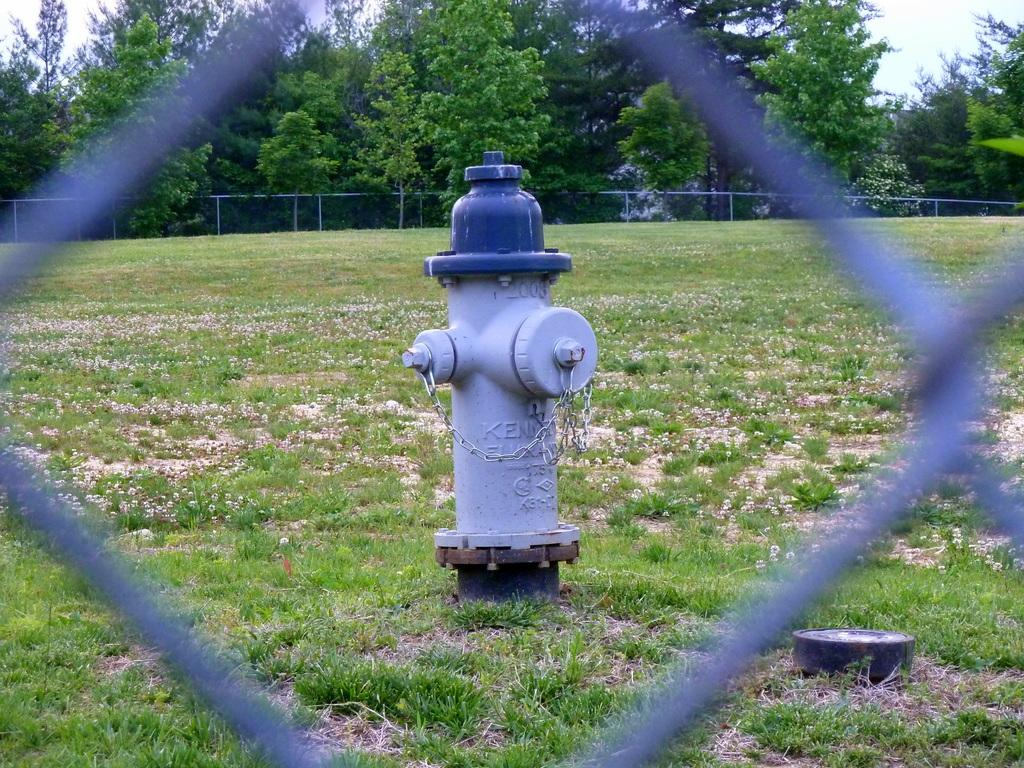What is the main object in the center of the image? There is a fire extinguisher in the center of the image. What can be seen in the foreground of the image? There is a fence in the foreground of the image. What type of vegetation is present at the bottom of the image? Grass is present at the bottom of the image. What is visible in the background of the image? There is a net and trees in the background of the image. What type of fruit is hanging from the icicle in the image? There is no icicle or fruit present in the image. 